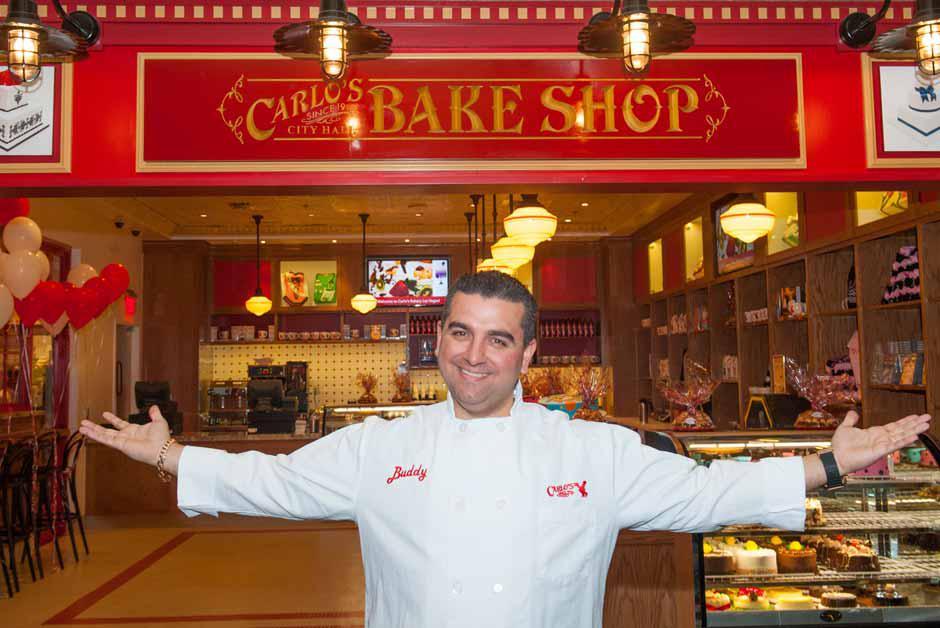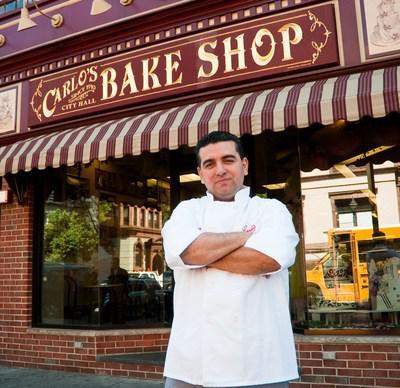The first image is the image on the left, the second image is the image on the right. Analyze the images presented: Is the assertion "There is a man with his  palms facing up." valid? Answer yes or no. Yes. 